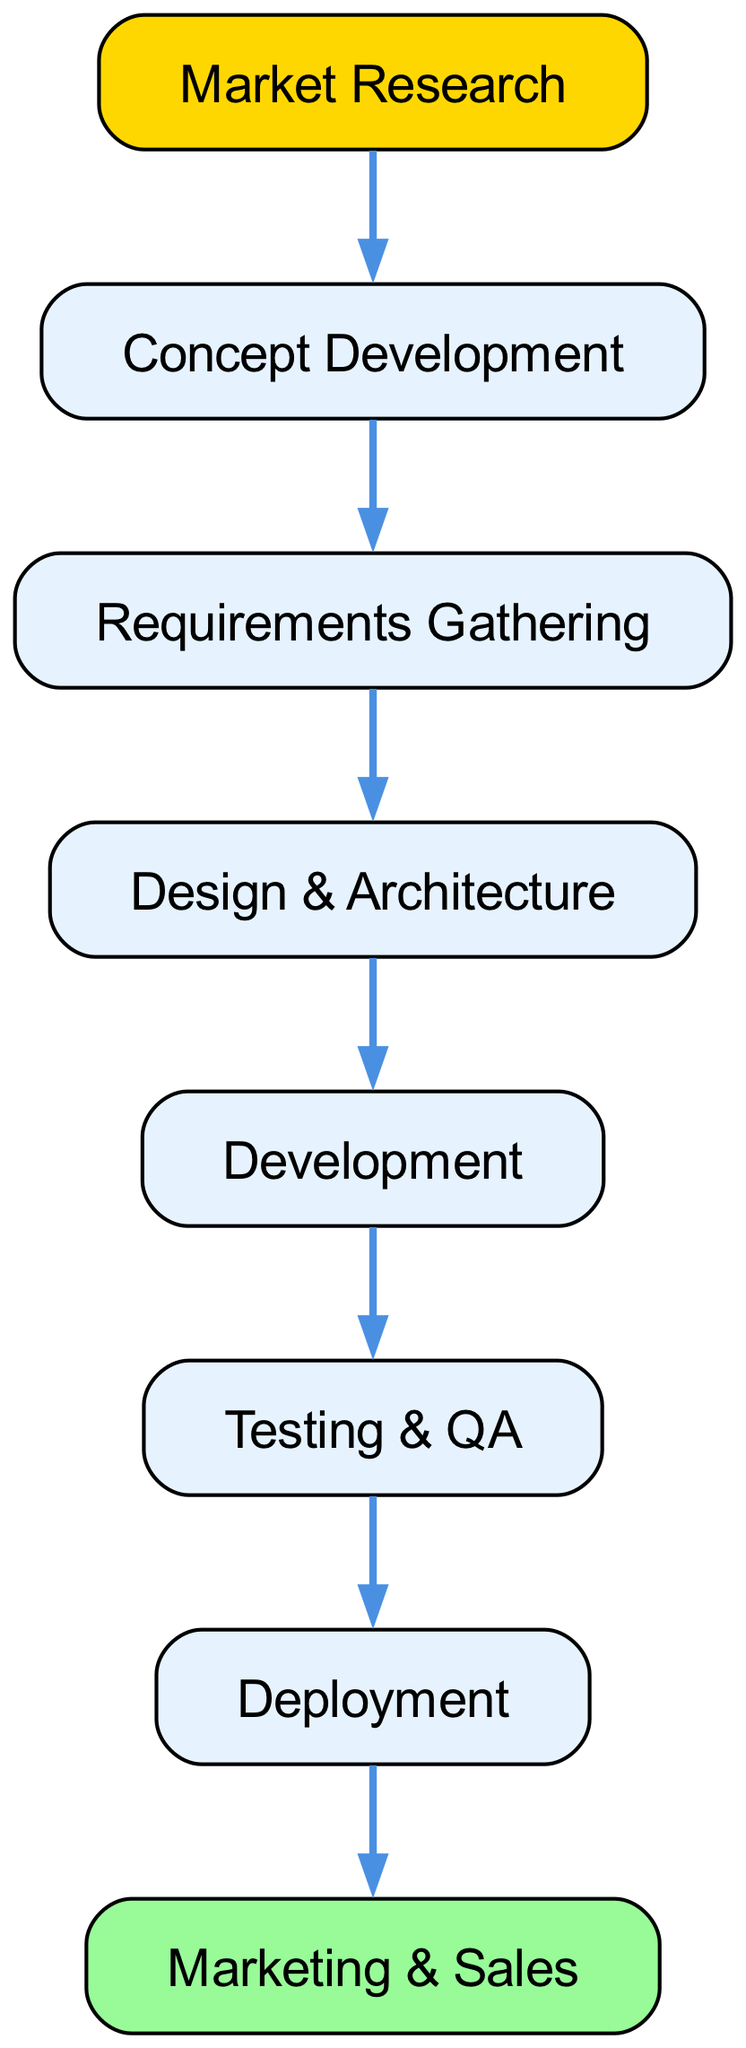What is the first step in the software development lifecycle? The first step in the diagram is "Market Research," which appears at the top of the flow. There are no other nodes preceding it.
Answer: Market Research How many nodes are in the diagram? By counting the entries in the provided data, we can identify a total of eight nodes. Each entry in the elements list represents one node within the diagram.
Answer: Eight Which step follows "Testing & QA"? According to the flow of the diagram, "Testing & QA" leads directly to "Deployment," which is the next node in the sequence.
Answer: Deployment What are the last two steps in the software development lifecycle? The last two nodes in the diagram are "Deployment" and "Marketing & Sales." "Deployment" connects to "Marketing & Sales," making them terminal stages in the lifecycle.
Answer: Deployment and Marketing & Sales Which step has the most number of dependencies? Analyzing the relationships reveals that "Development" is dependent on "Design & Architecture." However, two nodes precede it, making it pivotal, but "Marketing & Sales" also relies on "Deployment," revealing interconnected dependencies. Thus, "Deployment" has the ultimate dependency as it directly relies on "Testing & QA."
Answer: Deployment What does "Requirements Gathering" depend on? Looking at the edges leading to "Requirements Gathering," it is clear that it solely depends on "Concept Development," making it directly tied to that node.
Answer: Concept Development Identify a step that has no dependencies. According to the diagram, "Market Research" is the only step with no incoming edges, meaning it does not rely on any prior steps for its initiation in the workflow.
Answer: Market Research Which two steps are directly linked? The edge connection from "Testing & QA" to "Deployment" indicates a direct link; there are no intervening steps.
Answer: Testing & QA and Deployment 